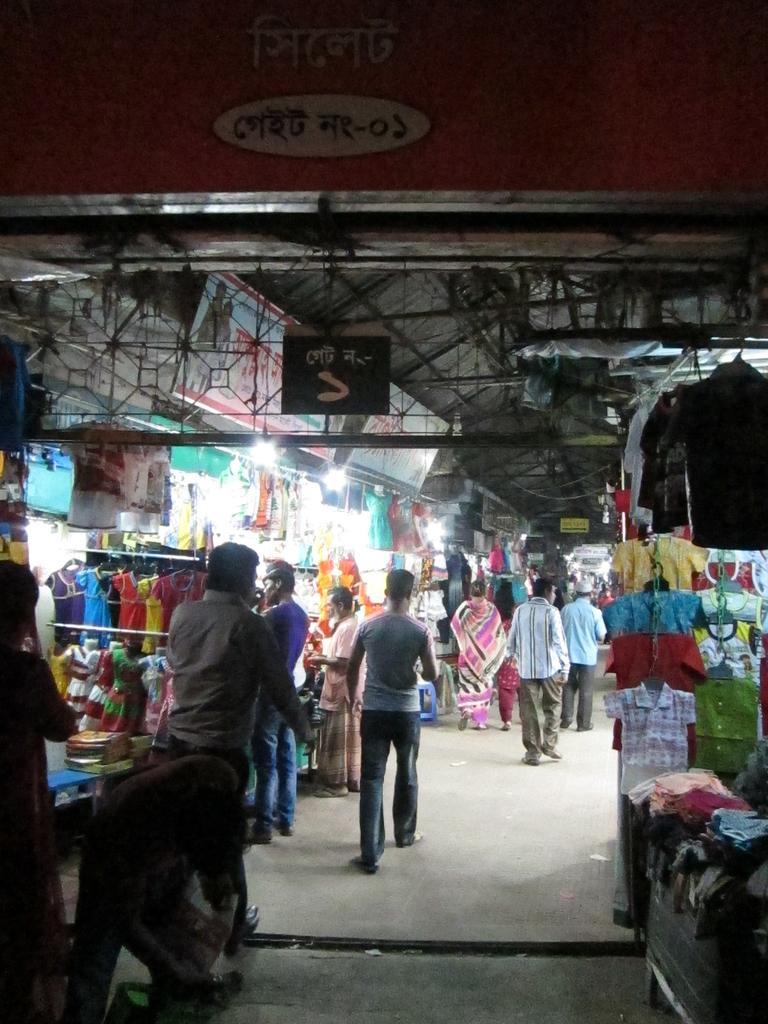Could you give a brief overview of what you see in this image? In this image we can see a group of people walking on a pathway. We can also see some clothes hanged to a hanger, mannequins with dresses, some folded clothes on a table, chairs, a banner and some lights. On the top of the image we can see a board with some text and a roof. 